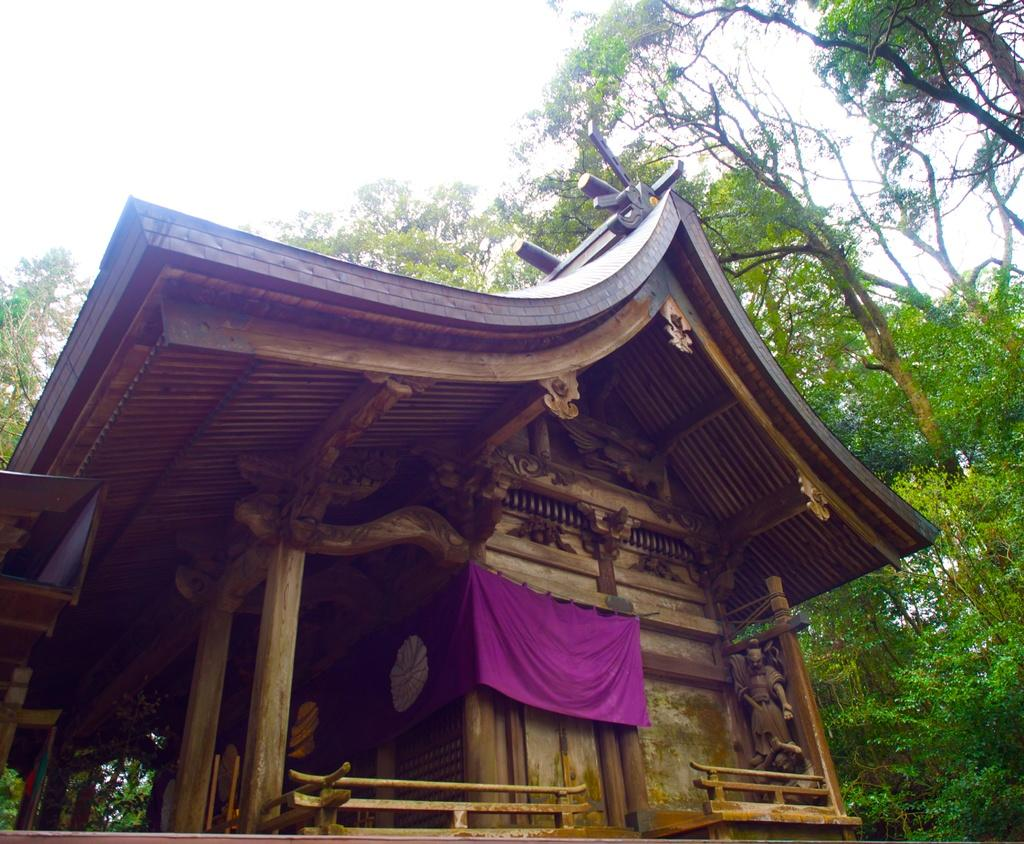What is the main structure in the center of the image? There is a shed in the center of the image. What decorations are on the shed? Sculptures are carved on the shed. What can be seen flying in the image? There is a flag in the image. What type of natural environment is visible in the background of the image? There are trees and the sky visible in the background of the image. What type of shoe can be seen hanging from the shed in the image? There is no shoe present on the shed in the image. What type of animal can be seen interacting with the sculptures on the shed? There are no animals interacting with the sculptures on the shed in the image. 